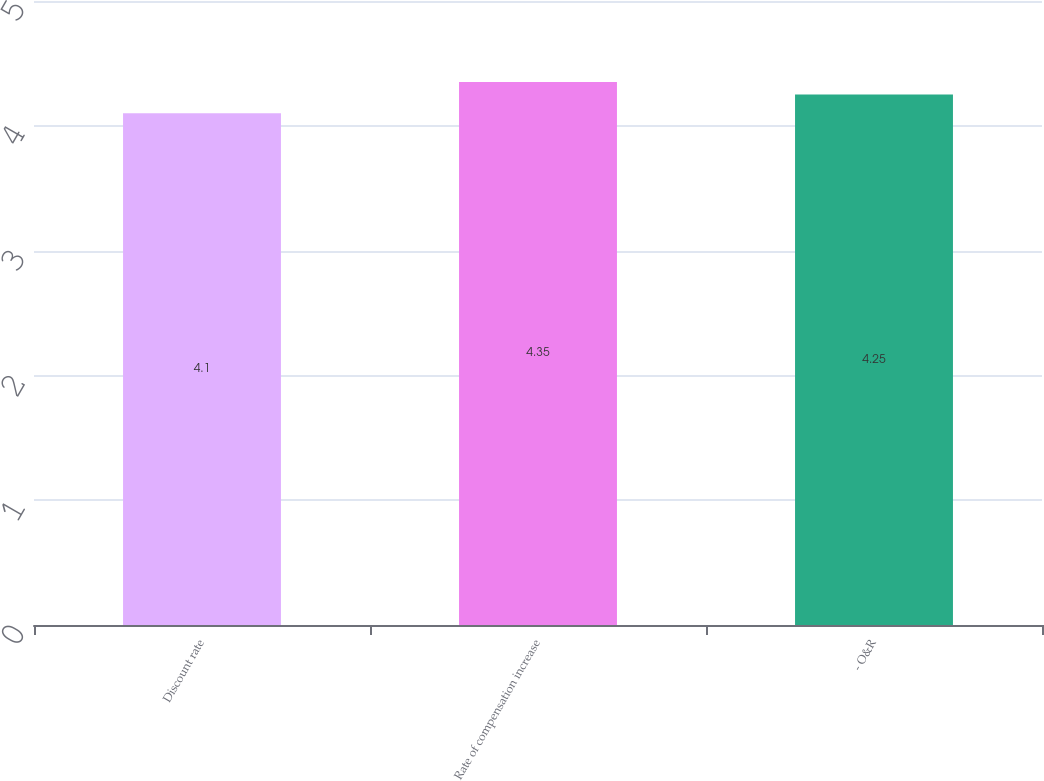<chart> <loc_0><loc_0><loc_500><loc_500><bar_chart><fcel>Discount rate<fcel>Rate of compensation increase<fcel>- O&R<nl><fcel>4.1<fcel>4.35<fcel>4.25<nl></chart> 